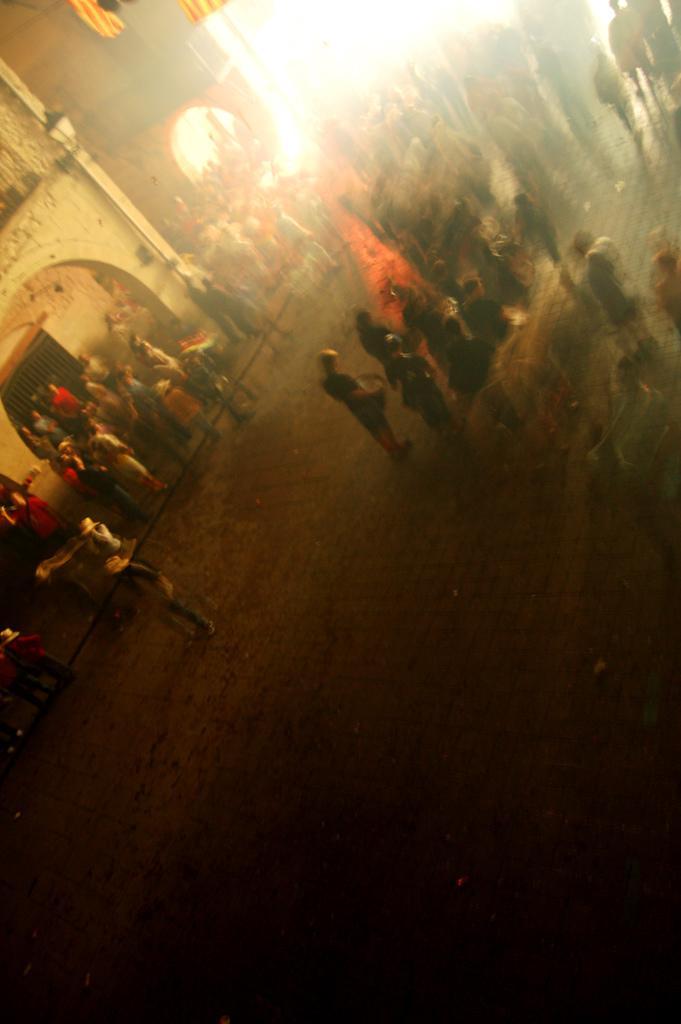Describe this image in one or two sentences. In this image few persons are standing on the floor. Few persons are standing on the pavement. Behind them there are buildings. Top of image there are few flags. 